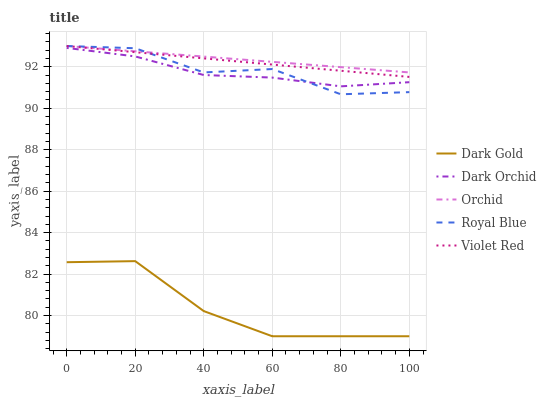Does Dark Gold have the minimum area under the curve?
Answer yes or no. Yes. Does Orchid have the maximum area under the curve?
Answer yes or no. Yes. Does Violet Red have the minimum area under the curve?
Answer yes or no. No. Does Violet Red have the maximum area under the curve?
Answer yes or no. No. Is Violet Red the smoothest?
Answer yes or no. Yes. Is Royal Blue the roughest?
Answer yes or no. Yes. Is Dark Orchid the smoothest?
Answer yes or no. No. Is Dark Orchid the roughest?
Answer yes or no. No. Does Dark Gold have the lowest value?
Answer yes or no. Yes. Does Violet Red have the lowest value?
Answer yes or no. No. Does Orchid have the highest value?
Answer yes or no. Yes. Does Dark Orchid have the highest value?
Answer yes or no. No. Is Dark Orchid less than Orchid?
Answer yes or no. Yes. Is Violet Red greater than Dark Gold?
Answer yes or no. Yes. Does Dark Orchid intersect Royal Blue?
Answer yes or no. Yes. Is Dark Orchid less than Royal Blue?
Answer yes or no. No. Is Dark Orchid greater than Royal Blue?
Answer yes or no. No. Does Dark Orchid intersect Orchid?
Answer yes or no. No. 